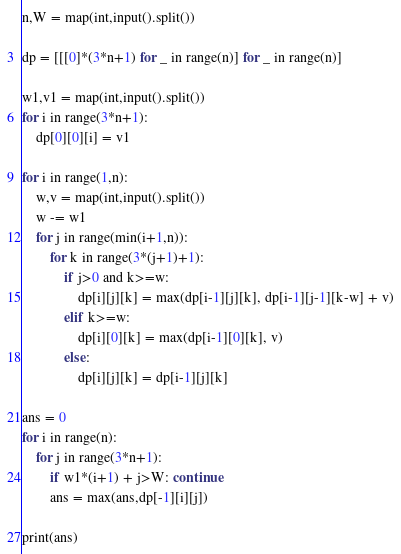<code> <loc_0><loc_0><loc_500><loc_500><_Python_>n,W = map(int,input().split())

dp = [[[0]*(3*n+1) for _ in range(n)] for _ in range(n)]

w1,v1 = map(int,input().split())
for i in range(3*n+1):
    dp[0][0][i] = v1

for i in range(1,n):
    w,v = map(int,input().split())
    w -= w1
    for j in range(min(i+1,n)):
        for k in range(3*(j+1)+1):
            if j>0 and k>=w:
                dp[i][j][k] = max(dp[i-1][j][k], dp[i-1][j-1][k-w] + v)
            elif k>=w:
                dp[i][0][k] = max(dp[i-1][0][k], v)
            else:
                dp[i][j][k] = dp[i-1][j][k]

ans = 0
for i in range(n):
    for j in range(3*n+1):
        if w1*(i+1) + j>W: continue
        ans = max(ans,dp[-1][i][j])

print(ans)</code> 